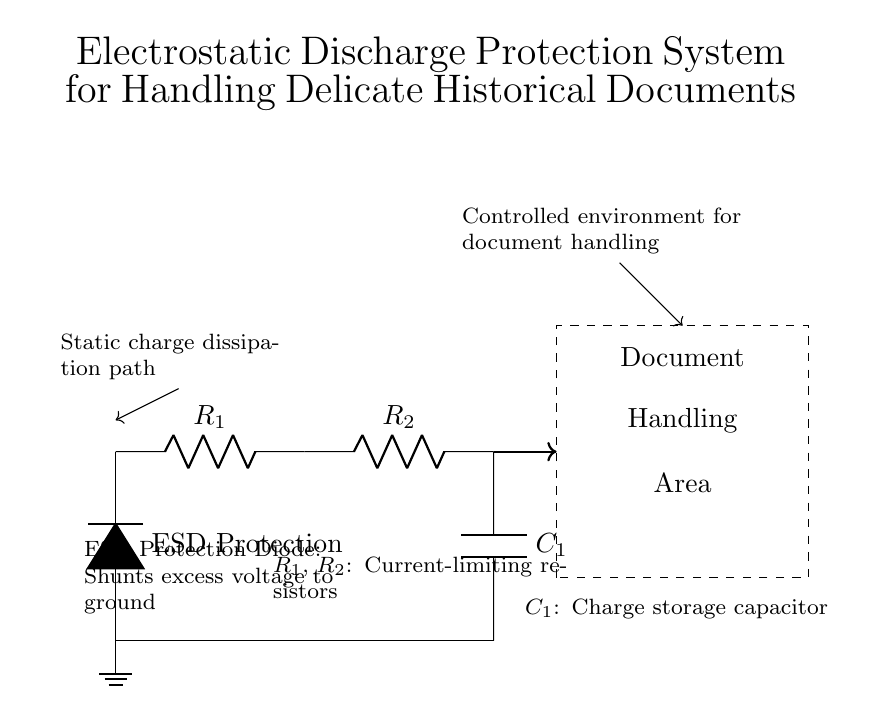What type of component is connected to ground? The component connected to ground in this circuit is the ESD protection diode, which helps shunt excess voltage safely to the ground.
Answer: ESD protection diode What do the current-limiting resistors R1 and R2 do? The current-limiting resistors R1 and R2 are used to limit the amount of current flowing into the circuit, preventing damage to sensitive components from excess current.
Answer: Limit current What is the function of the capacitor C1? The function of capacitor C1 is to store charge, helping to maintain voltage stability in the circuit during transient events like electrostatic discharge.
Answer: Charge storage Why is there a dashed rectangle in the diagram? The dashed rectangle represents the document handling area, highlighting the space where delicate historical documents are manipulated and emphasizing the controlled environment required for their safe handling.
Answer: Document handling area How does the ESD protection diode contribute to static charge management? The ESD protection diode allows excess voltage to be shunted safely to the ground, providing a dissipation path for static charge and protecting the circuit components and documents from damage.
Answer: Shunts excess voltage What happens when the static charge exceeds the diode's threshold? When the static charge exceeds the diode's threshold, it will conduct, allowing the excess voltage to flow to the ground, thus protecting the downstream components from high voltage spikes.
Answer: Conducts to ground 